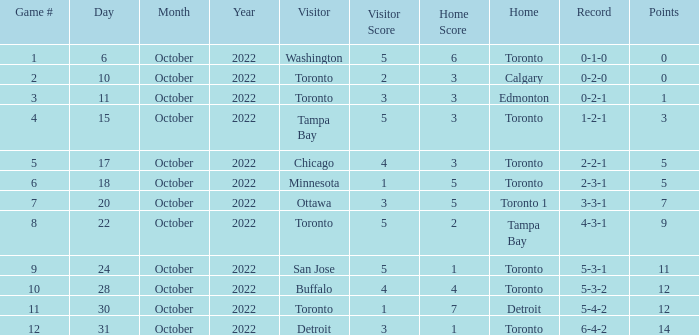What is the score when the record was 5-4-2? 1 - 7. 